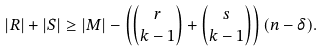Convert formula to latex. <formula><loc_0><loc_0><loc_500><loc_500>| R | + | S | \geq | M | - \left ( \binom { r } { k - 1 } + \binom { s } { k - 1 } \right ) ( n - \delta ) .</formula> 